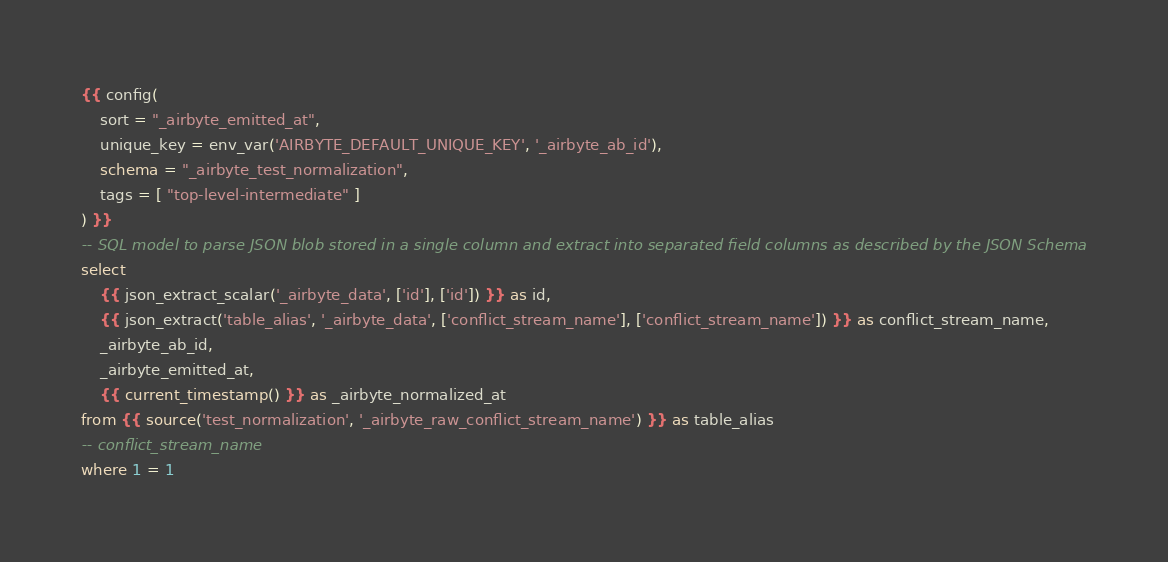<code> <loc_0><loc_0><loc_500><loc_500><_SQL_>{{ config(
    sort = "_airbyte_emitted_at",
    unique_key = env_var('AIRBYTE_DEFAULT_UNIQUE_KEY', '_airbyte_ab_id'),
    schema = "_airbyte_test_normalization",
    tags = [ "top-level-intermediate" ]
) }}
-- SQL model to parse JSON blob stored in a single column and extract into separated field columns as described by the JSON Schema
select
    {{ json_extract_scalar('_airbyte_data', ['id'], ['id']) }} as id,
    {{ json_extract('table_alias', '_airbyte_data', ['conflict_stream_name'], ['conflict_stream_name']) }} as conflict_stream_name,
    _airbyte_ab_id,
    _airbyte_emitted_at,
    {{ current_timestamp() }} as _airbyte_normalized_at
from {{ source('test_normalization', '_airbyte_raw_conflict_stream_name') }} as table_alias
-- conflict_stream_name
where 1 = 1

</code> 